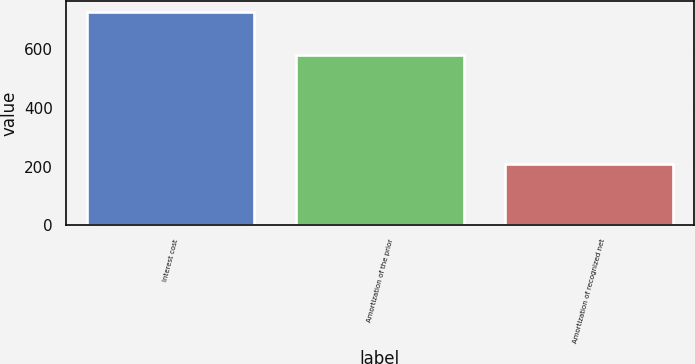Convert chart to OTSL. <chart><loc_0><loc_0><loc_500><loc_500><bar_chart><fcel>Interest cost<fcel>Amortization of the prior<fcel>Amortization of recognized net<nl><fcel>726<fcel>581<fcel>210<nl></chart> 